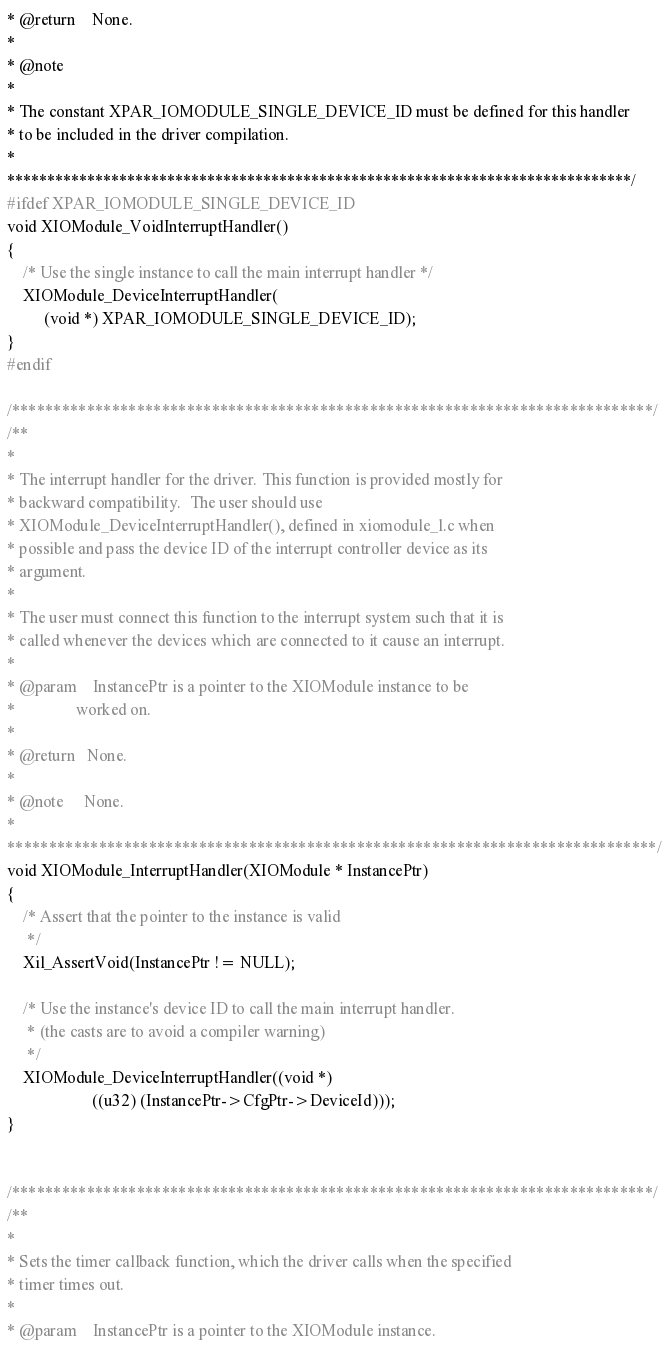Convert code to text. <code><loc_0><loc_0><loc_500><loc_500><_C_>* @return	None.
*
* @note
*
* The constant XPAR_IOMODULE_SINGLE_DEVICE_ID must be defined for this handler
* to be included in the driver compilation.
*
******************************************************************************/
#ifdef XPAR_IOMODULE_SINGLE_DEVICE_ID
void XIOModule_VoidInterruptHandler()
{
	/* Use the single instance to call the main interrupt handler */
	XIOModule_DeviceInterruptHandler(
		 (void *) XPAR_IOMODULE_SINGLE_DEVICE_ID);
}
#endif

/*****************************************************************************/
/**
*
* The interrupt handler for the driver. This function is provided mostly for
* backward compatibility.  The user should use
* XIOModule_DeviceInterruptHandler(), defined in xiomodule_l.c when
* possible and pass the device ID of the interrupt controller device as its
* argument.
*
* The user must connect this function to the interrupt system such that it is
* called whenever the devices which are connected to it cause an interrupt.
*
* @param	InstancePtr is a pointer to the XIOModule instance to be
*               worked on.
*
* @return	None.
*
* @note		None.
*
******************************************************************************/
void XIOModule_InterruptHandler(XIOModule * InstancePtr)
{
	/* Assert that the pointer to the instance is valid
	 */
	Xil_AssertVoid(InstancePtr != NULL);

	/* Use the instance's device ID to call the main interrupt handler.
	 * (the casts are to avoid a compiler warning)
	 */
	XIOModule_DeviceInterruptHandler((void *)
			         ((u32) (InstancePtr->CfgPtr->DeviceId)));
}


/*****************************************************************************/
/**
*
* Sets the timer callback function, which the driver calls when the specified
* timer times out.
*
* @param	InstancePtr is a pointer to the XIOModule instance.</code> 